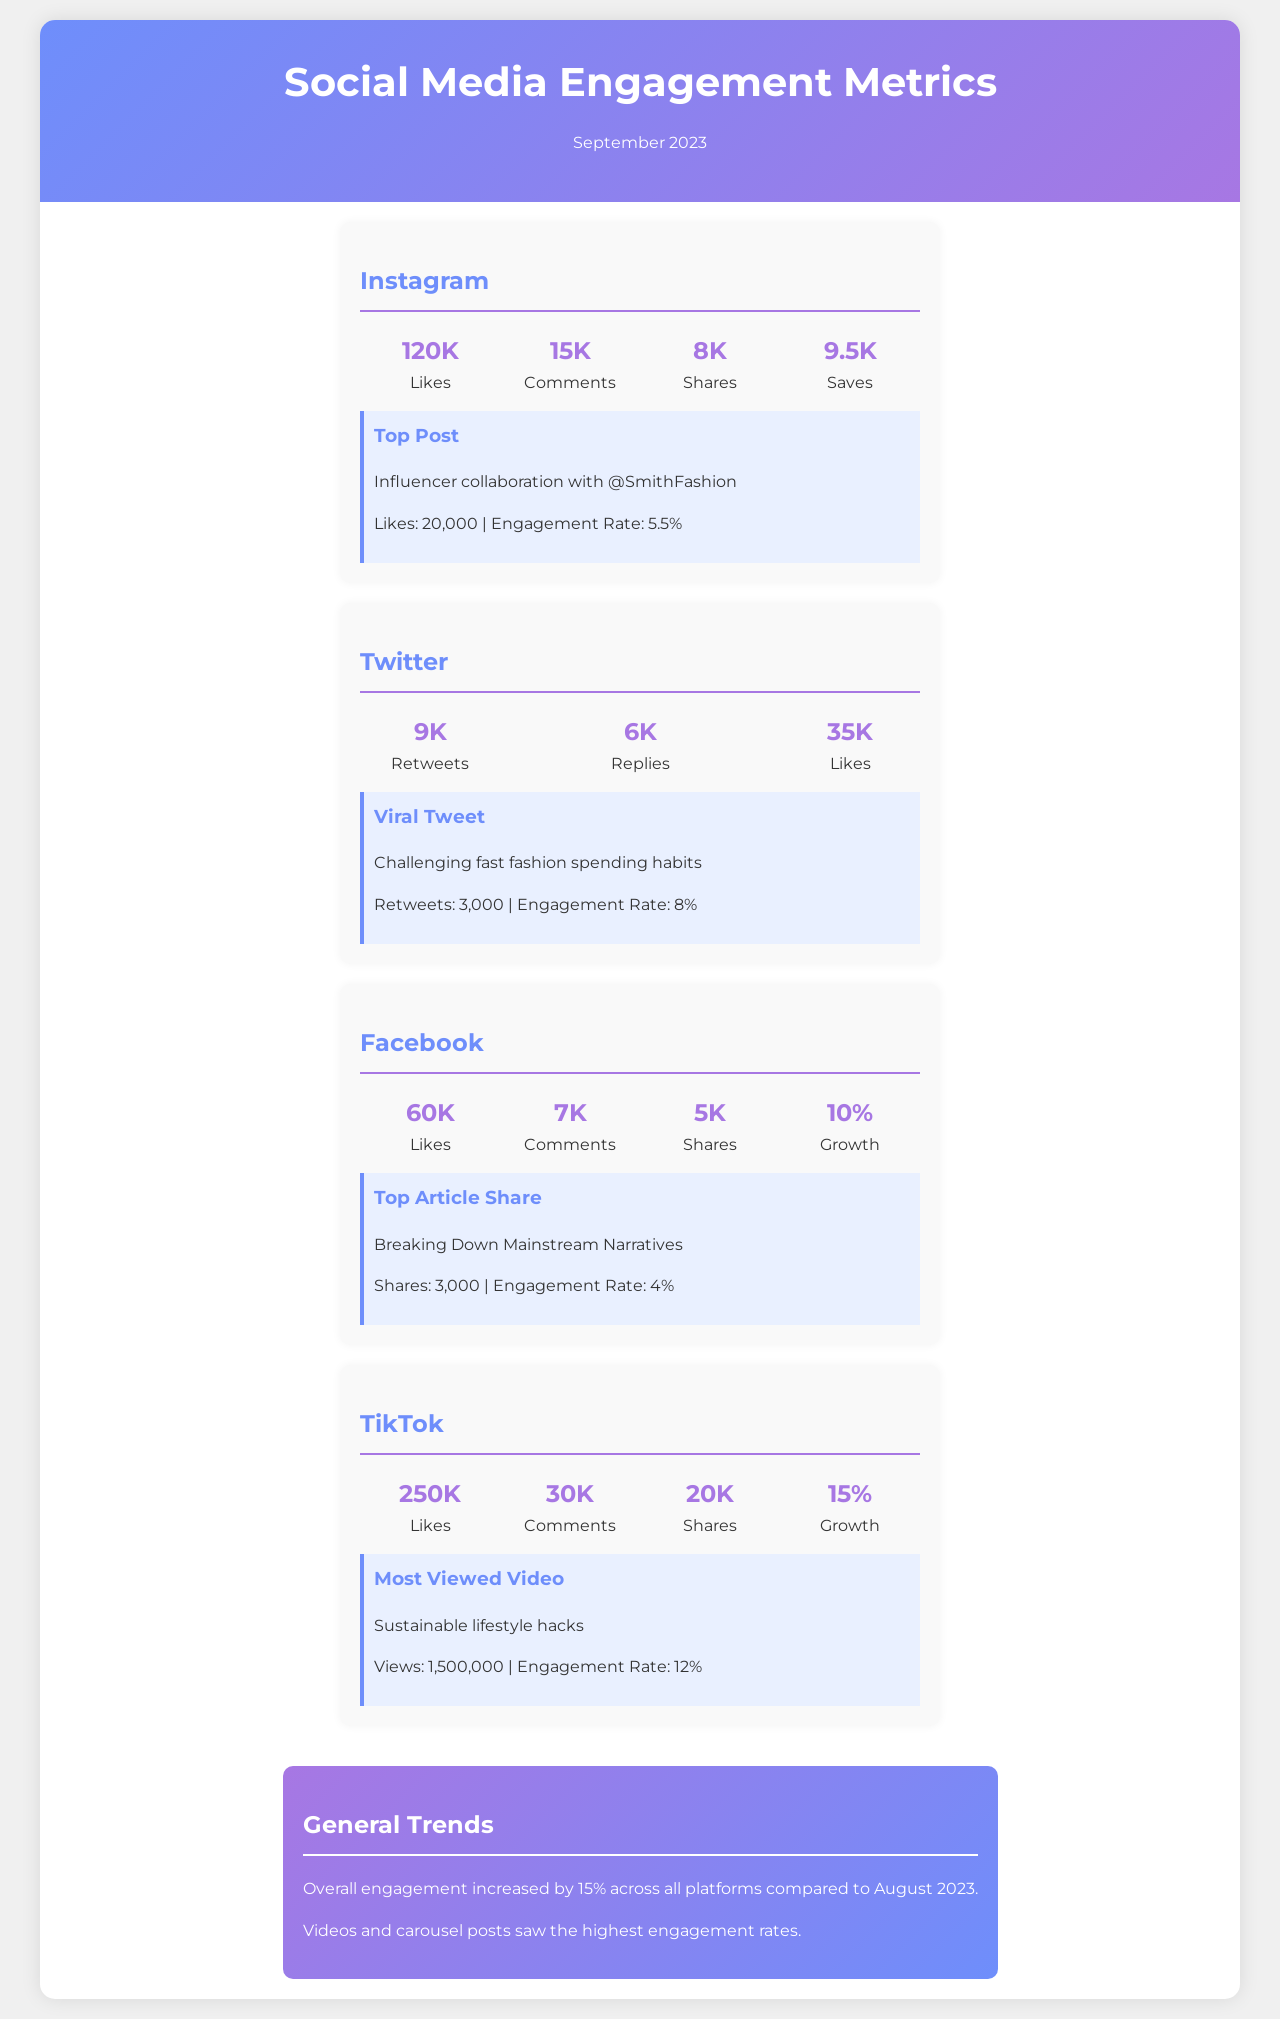What is the total number of likes on Instagram? The total number of likes on Instagram is mentioned as 120K.
Answer: 120K Which platform had the highest number of likes? Comparing the likes across platforms, TikTok had 250K, which is the highest.
Answer: TikTok What was the engagement rate of the top Instagram post? The engagement rate of the top Instagram post collaboration is given as 5.5%.
Answer: 5.5% How many shares did the viral tweet receive? The document states that the viral tweet received 3,000 retweets.
Answer: 3,000 What was the growth percentage on Facebook? The growth percentage on Facebook is indicated as 10%.
Answer: 10% Which type of post saw the highest engagement rates overall? The document notes that videos and carousel posts had the highest engagement rates.
Answer: Videos and carousel posts What is the engagement rate of the most viewed TikTok video? The engagement rate of the most viewed TikTok video is provided as 12%.
Answer: 12% What is the total number of comments on LinkedIn? The document does not mention LinkedIn, so the answer does not apply.
Answer: N/A What theme did the top article shared on Facebook address? The top article shared on Facebook addresses breaking down mainstream narratives.
Answer: Breaking down mainstream narratives 